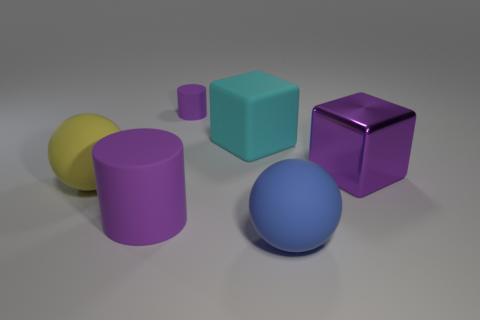Is there anything else that has the same material as the purple cube?
Your answer should be very brief. No. How many things are either big things to the left of the cyan matte cube or rubber balls in front of the small matte cylinder?
Provide a succinct answer. 3. What is the size of the rubber sphere right of the purple matte thing behind the purple rubber cylinder that is in front of the small matte object?
Offer a very short reply. Large. Are there an equal number of large blocks left of the big matte cube and big purple things?
Your answer should be very brief. No. Is there any other thing that has the same shape as the cyan thing?
Provide a succinct answer. Yes. There is a big blue object; is its shape the same as the purple matte thing that is behind the big yellow ball?
Your response must be concise. No. There is another matte object that is the same shape as the yellow object; what size is it?
Make the answer very short. Large. What number of other objects are the same material as the cyan object?
Make the answer very short. 4. What material is the tiny object?
Give a very brief answer. Rubber. Is the color of the small matte thing that is behind the large blue rubber ball the same as the matte cylinder that is in front of the cyan rubber thing?
Ensure brevity in your answer.  Yes. 